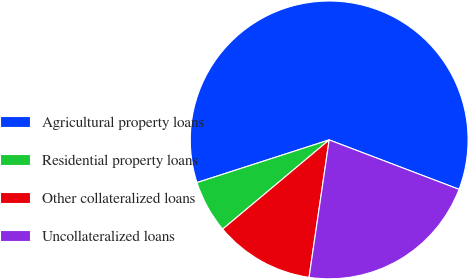<chart> <loc_0><loc_0><loc_500><loc_500><pie_chart><fcel>Agricultural property loans<fcel>Residential property loans<fcel>Other collateralized loans<fcel>Uncollateralized loans<nl><fcel>60.76%<fcel>6.13%<fcel>11.59%<fcel>21.53%<nl></chart> 